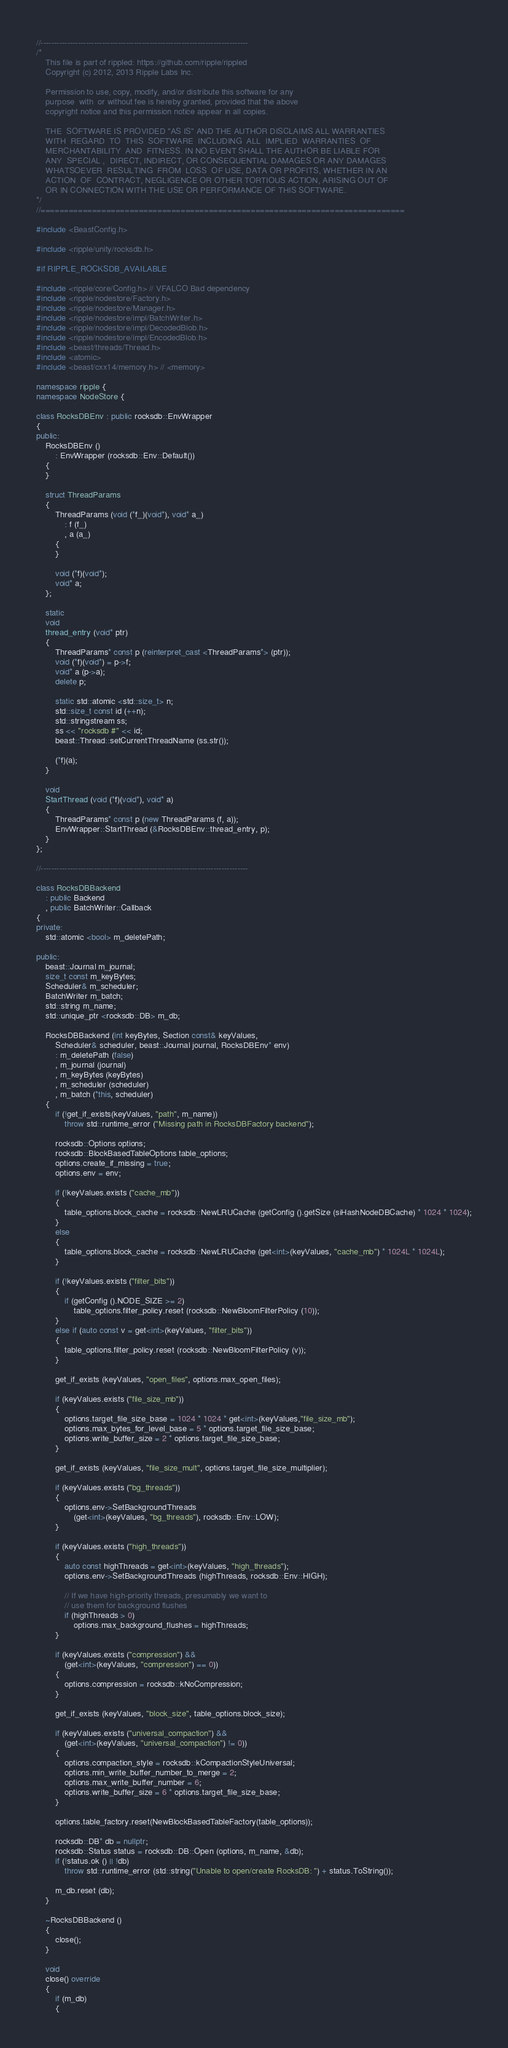<code> <loc_0><loc_0><loc_500><loc_500><_C++_>//------------------------------------------------------------------------------
/*
    This file is part of rippled: https://github.com/ripple/rippled
    Copyright (c) 2012, 2013 Ripple Labs Inc.

    Permission to use, copy, modify, and/or distribute this software for any
    purpose  with  or without fee is hereby granted, provided that the above
    copyright notice and this permission notice appear in all copies.

    THE  SOFTWARE IS PROVIDED "AS IS" AND THE AUTHOR DISCLAIMS ALL WARRANTIES
    WITH  REGARD  TO  THIS  SOFTWARE  INCLUDING  ALL  IMPLIED  WARRANTIES  OF
    MERCHANTABILITY  AND  FITNESS. IN NO EVENT SHALL THE AUTHOR BE LIABLE FOR
    ANY  SPECIAL ,  DIRECT, INDIRECT, OR CONSEQUENTIAL DAMAGES OR ANY DAMAGES
    WHATSOEVER  RESULTING  FROM  LOSS  OF USE, DATA OR PROFITS, WHETHER IN AN
    ACTION  OF  CONTRACT, NEGLIGENCE OR OTHER TORTIOUS ACTION, ARISING OUT OF
    OR IN CONNECTION WITH THE USE OR PERFORMANCE OF THIS SOFTWARE.
*/
//==============================================================================

#include <BeastConfig.h>

#include <ripple/unity/rocksdb.h>

#if RIPPLE_ROCKSDB_AVAILABLE

#include <ripple/core/Config.h> // VFALCO Bad dependency
#include <ripple/nodestore/Factory.h>
#include <ripple/nodestore/Manager.h>
#include <ripple/nodestore/impl/BatchWriter.h>
#include <ripple/nodestore/impl/DecodedBlob.h>
#include <ripple/nodestore/impl/EncodedBlob.h>
#include <beast/threads/Thread.h>
#include <atomic>
#include <beast/cxx14/memory.h> // <memory>

namespace ripple {
namespace NodeStore {

class RocksDBEnv : public rocksdb::EnvWrapper
{
public:
    RocksDBEnv ()
        : EnvWrapper (rocksdb::Env::Default())
    {
    }

    struct ThreadParams
    {
        ThreadParams (void (*f_)(void*), void* a_)
            : f (f_)
            , a (a_)
        {
        }

        void (*f)(void*);
        void* a;
    };

    static
    void
    thread_entry (void* ptr)
    {
        ThreadParams* const p (reinterpret_cast <ThreadParams*> (ptr));
        void (*f)(void*) = p->f;
        void* a (p->a);
        delete p;

        static std::atomic <std::size_t> n;
        std::size_t const id (++n);
        std::stringstream ss;
        ss << "rocksdb #" << id;
        beast::Thread::setCurrentThreadName (ss.str());

        (*f)(a);
    }

    void
    StartThread (void (*f)(void*), void* a)
    {
        ThreadParams* const p (new ThreadParams (f, a));
        EnvWrapper::StartThread (&RocksDBEnv::thread_entry, p);
    }
};

//------------------------------------------------------------------------------

class RocksDBBackend
    : public Backend
    , public BatchWriter::Callback
{
private:
    std::atomic <bool> m_deletePath;

public:
    beast::Journal m_journal;
    size_t const m_keyBytes;
    Scheduler& m_scheduler;
    BatchWriter m_batch;
    std::string m_name;
    std::unique_ptr <rocksdb::DB> m_db;

    RocksDBBackend (int keyBytes, Section const& keyValues,
        Scheduler& scheduler, beast::Journal journal, RocksDBEnv* env)
        : m_deletePath (false)
        , m_journal (journal)
        , m_keyBytes (keyBytes)
        , m_scheduler (scheduler)
        , m_batch (*this, scheduler)
    {
        if (!get_if_exists(keyValues, "path", m_name))
            throw std::runtime_error ("Missing path in RocksDBFactory backend");

        rocksdb::Options options;
        rocksdb::BlockBasedTableOptions table_options;
        options.create_if_missing = true;
        options.env = env;

        if (!keyValues.exists ("cache_mb"))
        {
            table_options.block_cache = rocksdb::NewLRUCache (getConfig ().getSize (siHashNodeDBCache) * 1024 * 1024);
        }
        else
        {
            table_options.block_cache = rocksdb::NewLRUCache (get<int>(keyValues, "cache_mb") * 1024L * 1024L);
        }

        if (!keyValues.exists ("filter_bits"))
        {
            if (getConfig ().NODE_SIZE >= 2)
                table_options.filter_policy.reset (rocksdb::NewBloomFilterPolicy (10));
        }
        else if (auto const v = get<int>(keyValues, "filter_bits"))
        {
            table_options.filter_policy.reset (rocksdb::NewBloomFilterPolicy (v));
        }

        get_if_exists (keyValues, "open_files", options.max_open_files);

        if (keyValues.exists ("file_size_mb"))
        {
            options.target_file_size_base = 1024 * 1024 * get<int>(keyValues,"file_size_mb");
            options.max_bytes_for_level_base = 5 * options.target_file_size_base;
            options.write_buffer_size = 2 * options.target_file_size_base;
        }

        get_if_exists (keyValues, "file_size_mult", options.target_file_size_multiplier);

        if (keyValues.exists ("bg_threads"))
        {
            options.env->SetBackgroundThreads
                (get<int>(keyValues, "bg_threads"), rocksdb::Env::LOW);
        }

        if (keyValues.exists ("high_threads"))
        {
            auto const highThreads = get<int>(keyValues, "high_threads");
            options.env->SetBackgroundThreads (highThreads, rocksdb::Env::HIGH);

            // If we have high-priority threads, presumably we want to
            // use them for background flushes
            if (highThreads > 0)
                options.max_background_flushes = highThreads;
        }

        if (keyValues.exists ("compression") &&
            (get<int>(keyValues, "compression") == 0))
        {
            options.compression = rocksdb::kNoCompression;
        }

        get_if_exists (keyValues, "block_size", table_options.block_size);

        if (keyValues.exists ("universal_compaction") &&
            (get<int>(keyValues, "universal_compaction") != 0))
        {
            options.compaction_style = rocksdb::kCompactionStyleUniversal;
            options.min_write_buffer_number_to_merge = 2;
            options.max_write_buffer_number = 6;
            options.write_buffer_size = 6 * options.target_file_size_base;
        }

        options.table_factory.reset(NewBlockBasedTableFactory(table_options));

        rocksdb::DB* db = nullptr;
        rocksdb::Status status = rocksdb::DB::Open (options, m_name, &db);
        if (!status.ok () || !db)
            throw std::runtime_error (std::string("Unable to open/create RocksDB: ") + status.ToString());

        m_db.reset (db);
    }

    ~RocksDBBackend ()
    {
        close();
    }

    void
    close() override
    {
        if (m_db)
        {</code> 